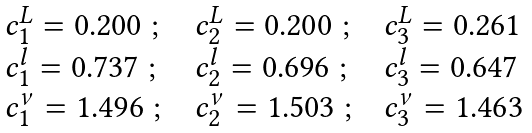Convert formula to latex. <formula><loc_0><loc_0><loc_500><loc_500>\begin{array} { l l l } c _ { 1 } ^ { L } = 0 . 2 0 0 \ ; \ \ & c _ { 2 } ^ { L } = 0 . 2 0 0 \ ; \ \ & c _ { 3 } ^ { L } = 0 . 2 6 1 \\ c _ { 1 } ^ { l } = 0 . 7 3 7 \ ; \ \ & c _ { 2 } ^ { l } = 0 . 6 9 6 \ ; \ \ & c _ { 3 } ^ { l } = 0 . 6 4 7 \\ c _ { 1 } ^ { \nu } = 1 . 4 9 6 \ ; \ \ & c _ { 2 } ^ { \nu } = 1 . 5 0 3 \ ; \ & c _ { 3 } ^ { \nu } = 1 . 4 6 3 \end{array}</formula> 